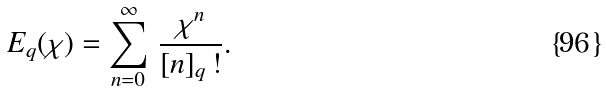<formula> <loc_0><loc_0><loc_500><loc_500>E _ { q } ( { \chi } ) = \sum _ { n = 0 } ^ { \infty } \, \frac { { \chi } ^ { n } } { [ n ] _ { q } \, ! } .</formula> 